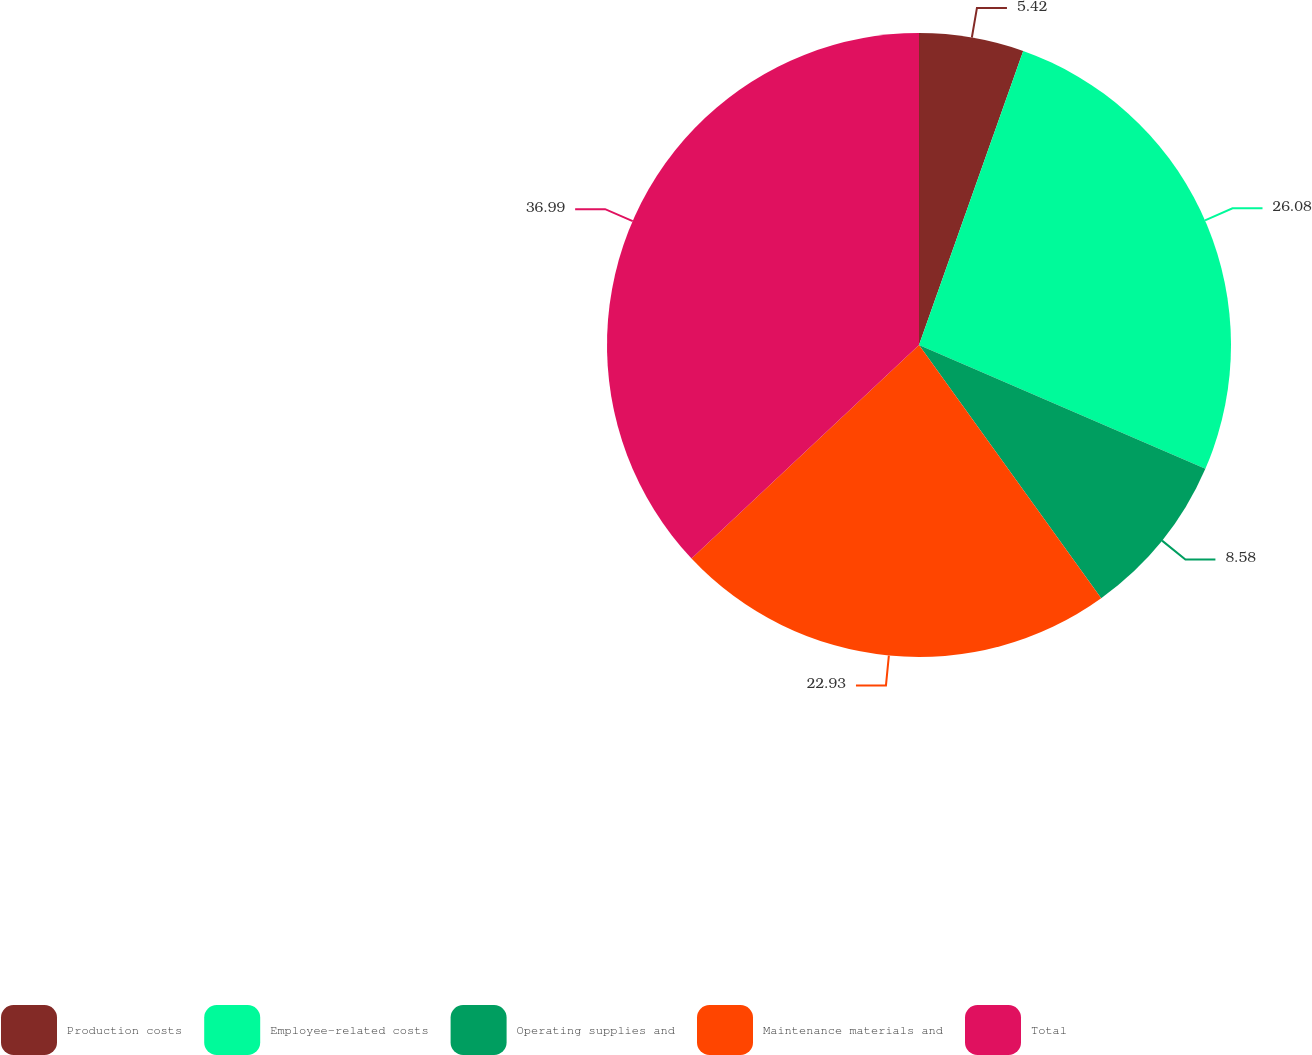<chart> <loc_0><loc_0><loc_500><loc_500><pie_chart><fcel>Production costs<fcel>Employee-related costs<fcel>Operating supplies and<fcel>Maintenance materials and<fcel>Total<nl><fcel>5.42%<fcel>26.08%<fcel>8.58%<fcel>22.93%<fcel>37.0%<nl></chart> 